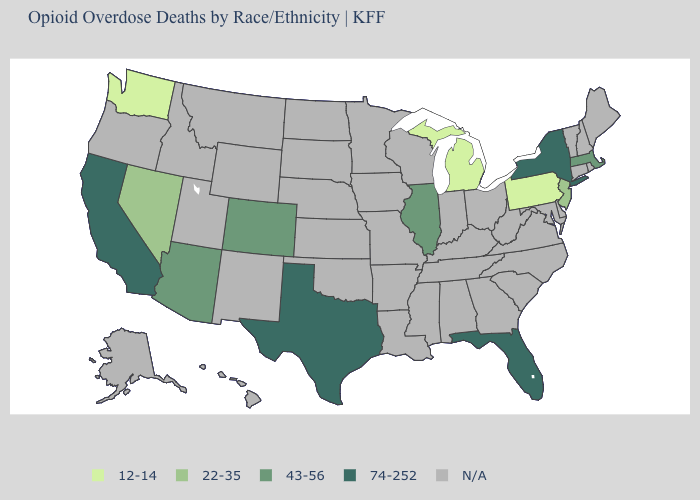What is the value of South Dakota?
Concise answer only. N/A. What is the value of Nebraska?
Concise answer only. N/A. Name the states that have a value in the range 22-35?
Give a very brief answer. Nevada, New Jersey. Name the states that have a value in the range 12-14?
Concise answer only. Michigan, Pennsylvania, Washington. Name the states that have a value in the range 74-252?
Give a very brief answer. California, Florida, New York, Texas. Is the legend a continuous bar?
Write a very short answer. No. What is the value of Oklahoma?
Answer briefly. N/A. What is the value of Mississippi?
Be succinct. N/A. Name the states that have a value in the range N/A?
Give a very brief answer. Alabama, Alaska, Arkansas, Connecticut, Delaware, Georgia, Hawaii, Idaho, Indiana, Iowa, Kansas, Kentucky, Louisiana, Maine, Maryland, Minnesota, Mississippi, Missouri, Montana, Nebraska, New Hampshire, New Mexico, North Carolina, North Dakota, Ohio, Oklahoma, Oregon, Rhode Island, South Carolina, South Dakota, Tennessee, Utah, Vermont, Virginia, West Virginia, Wisconsin, Wyoming. Name the states that have a value in the range 43-56?
Concise answer only. Arizona, Colorado, Illinois, Massachusetts. Name the states that have a value in the range 43-56?
Write a very short answer. Arizona, Colorado, Illinois, Massachusetts. 